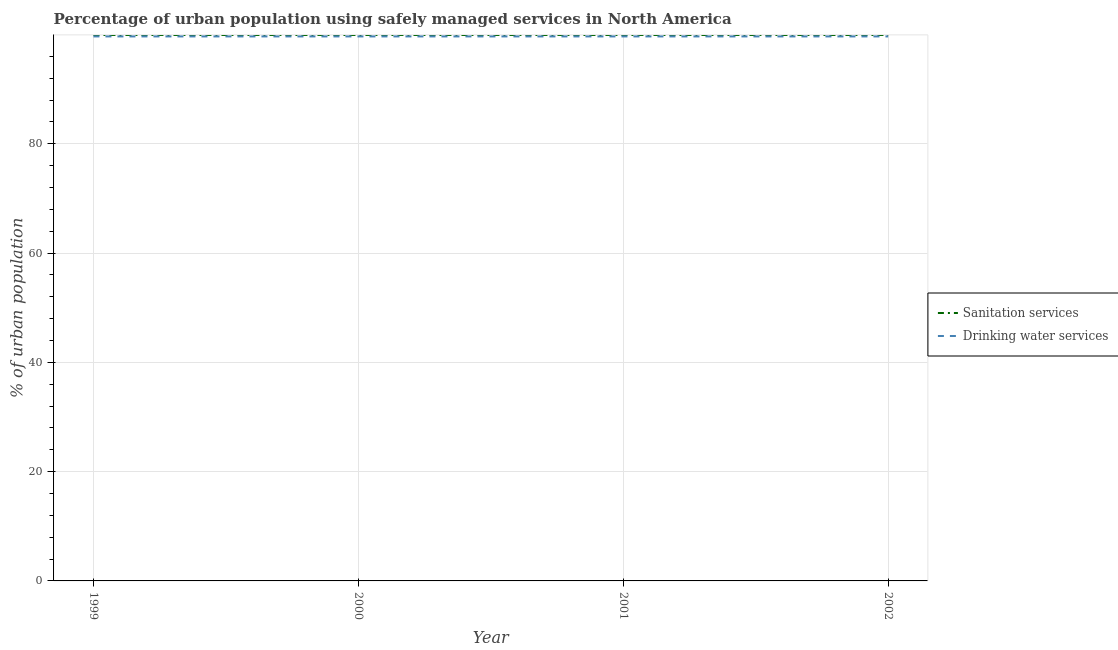Does the line corresponding to percentage of urban population who used drinking water services intersect with the line corresponding to percentage of urban population who used sanitation services?
Your response must be concise. No. Is the number of lines equal to the number of legend labels?
Your answer should be very brief. Yes. What is the percentage of urban population who used sanitation services in 2002?
Provide a succinct answer. 99.91. Across all years, what is the maximum percentage of urban population who used sanitation services?
Keep it short and to the point. 99.91. Across all years, what is the minimum percentage of urban population who used drinking water services?
Make the answer very short. 99.64. In which year was the percentage of urban population who used drinking water services maximum?
Make the answer very short. 2001. What is the total percentage of urban population who used drinking water services in the graph?
Provide a short and direct response. 398.56. What is the difference between the percentage of urban population who used drinking water services in 1999 and that in 2000?
Make the answer very short. 5.5618380628175146e-5. What is the difference between the percentage of urban population who used sanitation services in 1999 and the percentage of urban population who used drinking water services in 2000?
Your answer should be very brief. 0.27. What is the average percentage of urban population who used sanitation services per year?
Offer a terse response. 99.91. In the year 2000, what is the difference between the percentage of urban population who used drinking water services and percentage of urban population who used sanitation services?
Offer a terse response. -0.27. What is the ratio of the percentage of urban population who used sanitation services in 2000 to that in 2001?
Give a very brief answer. 1. Is the difference between the percentage of urban population who used sanitation services in 1999 and 2000 greater than the difference between the percentage of urban population who used drinking water services in 1999 and 2000?
Your answer should be compact. No. What is the difference between the highest and the second highest percentage of urban population who used drinking water services?
Your response must be concise. 2.030517549655997e-5. What is the difference between the highest and the lowest percentage of urban population who used drinking water services?
Ensure brevity in your answer.  7.592355612473511e-5. In how many years, is the percentage of urban population who used drinking water services greater than the average percentage of urban population who used drinking water services taken over all years?
Offer a terse response. 2. How many years are there in the graph?
Give a very brief answer. 4. What is the difference between two consecutive major ticks on the Y-axis?
Make the answer very short. 20. Are the values on the major ticks of Y-axis written in scientific E-notation?
Give a very brief answer. No. Does the graph contain any zero values?
Your answer should be very brief. No. Does the graph contain grids?
Keep it short and to the point. Yes. Where does the legend appear in the graph?
Keep it short and to the point. Center right. What is the title of the graph?
Ensure brevity in your answer.  Percentage of urban population using safely managed services in North America. Does "Commercial service imports" appear as one of the legend labels in the graph?
Offer a very short reply. No. What is the label or title of the X-axis?
Ensure brevity in your answer.  Year. What is the label or title of the Y-axis?
Your answer should be compact. % of urban population. What is the % of urban population of Sanitation services in 1999?
Give a very brief answer. 99.91. What is the % of urban population in Drinking water services in 1999?
Your response must be concise. 99.64. What is the % of urban population of Sanitation services in 2000?
Provide a short and direct response. 99.91. What is the % of urban population in Drinking water services in 2000?
Your answer should be very brief. 99.64. What is the % of urban population in Sanitation services in 2001?
Ensure brevity in your answer.  99.91. What is the % of urban population of Drinking water services in 2001?
Your answer should be very brief. 99.64. What is the % of urban population in Sanitation services in 2002?
Offer a terse response. 99.91. What is the % of urban population of Drinking water services in 2002?
Keep it short and to the point. 99.64. Across all years, what is the maximum % of urban population of Sanitation services?
Keep it short and to the point. 99.91. Across all years, what is the maximum % of urban population in Drinking water services?
Offer a terse response. 99.64. Across all years, what is the minimum % of urban population of Sanitation services?
Keep it short and to the point. 99.91. Across all years, what is the minimum % of urban population in Drinking water services?
Provide a short and direct response. 99.64. What is the total % of urban population of Sanitation services in the graph?
Your answer should be very brief. 399.64. What is the total % of urban population in Drinking water services in the graph?
Give a very brief answer. 398.56. What is the difference between the % of urban population in Drinking water services in 1999 and that in 2000?
Offer a terse response. 0. What is the difference between the % of urban population in Sanitation services in 1999 and that in 2001?
Keep it short and to the point. -0. What is the difference between the % of urban population in Drinking water services in 1999 and that in 2001?
Give a very brief answer. -0. What is the difference between the % of urban population in Sanitation services in 2000 and that in 2001?
Keep it short and to the point. -0. What is the difference between the % of urban population in Drinking water services in 2000 and that in 2001?
Your answer should be compact. -0. What is the difference between the % of urban population of Sanitation services in 1999 and the % of urban population of Drinking water services in 2000?
Your answer should be compact. 0.27. What is the difference between the % of urban population of Sanitation services in 1999 and the % of urban population of Drinking water services in 2001?
Your answer should be compact. 0.27. What is the difference between the % of urban population of Sanitation services in 1999 and the % of urban population of Drinking water services in 2002?
Give a very brief answer. 0.27. What is the difference between the % of urban population of Sanitation services in 2000 and the % of urban population of Drinking water services in 2001?
Offer a very short reply. 0.27. What is the difference between the % of urban population in Sanitation services in 2000 and the % of urban population in Drinking water services in 2002?
Your answer should be compact. 0.27. What is the difference between the % of urban population of Sanitation services in 2001 and the % of urban population of Drinking water services in 2002?
Provide a succinct answer. 0.27. What is the average % of urban population in Sanitation services per year?
Offer a very short reply. 99.91. What is the average % of urban population in Drinking water services per year?
Give a very brief answer. 99.64. In the year 1999, what is the difference between the % of urban population in Sanitation services and % of urban population in Drinking water services?
Offer a very short reply. 0.27. In the year 2000, what is the difference between the % of urban population in Sanitation services and % of urban population in Drinking water services?
Make the answer very short. 0.27. In the year 2001, what is the difference between the % of urban population of Sanitation services and % of urban population of Drinking water services?
Your answer should be very brief. 0.27. In the year 2002, what is the difference between the % of urban population of Sanitation services and % of urban population of Drinking water services?
Your answer should be compact. 0.27. What is the ratio of the % of urban population in Sanitation services in 1999 to that in 2000?
Provide a succinct answer. 1. What is the ratio of the % of urban population of Drinking water services in 1999 to that in 2000?
Give a very brief answer. 1. What is the ratio of the % of urban population of Sanitation services in 1999 to that in 2001?
Your answer should be compact. 1. What is the ratio of the % of urban population of Drinking water services in 1999 to that in 2001?
Offer a terse response. 1. What is the ratio of the % of urban population in Drinking water services in 1999 to that in 2002?
Provide a short and direct response. 1. What is the ratio of the % of urban population of Drinking water services in 2000 to that in 2001?
Your answer should be compact. 1. What is the ratio of the % of urban population of Sanitation services in 2001 to that in 2002?
Give a very brief answer. 1. What is the ratio of the % of urban population in Drinking water services in 2001 to that in 2002?
Provide a short and direct response. 1. What is the difference between the highest and the second highest % of urban population of Sanitation services?
Ensure brevity in your answer.  0. What is the difference between the highest and the lowest % of urban population of Drinking water services?
Offer a very short reply. 0. 